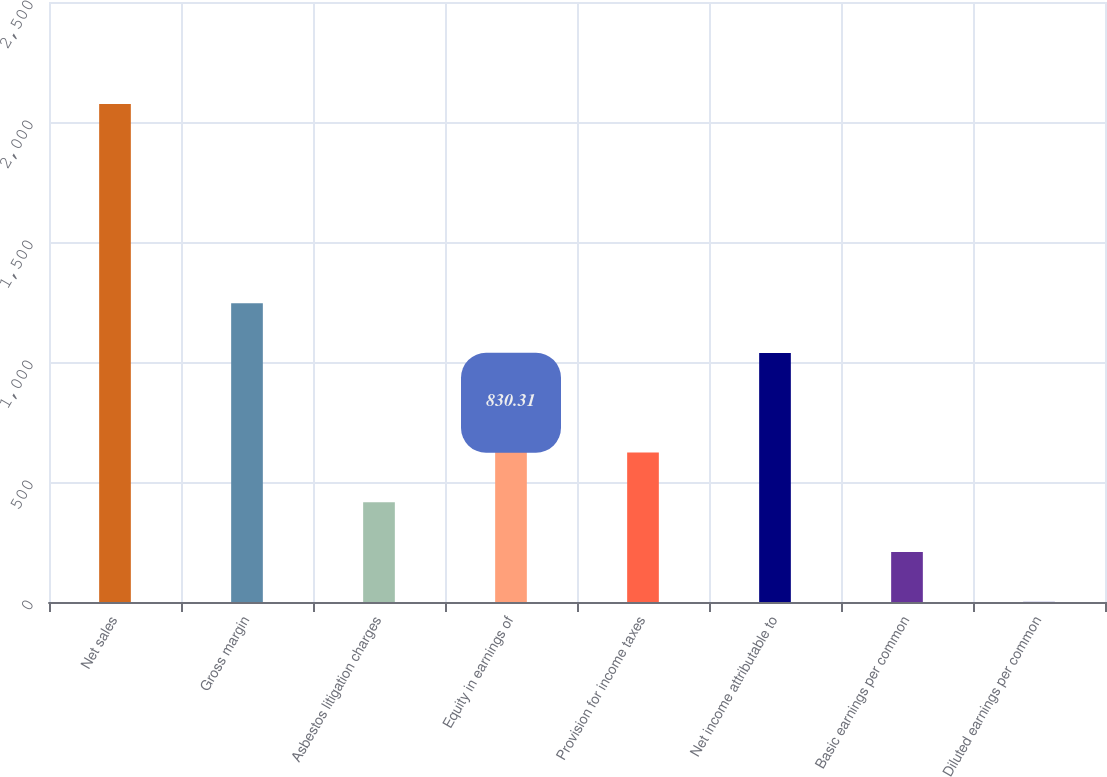Convert chart. <chart><loc_0><loc_0><loc_500><loc_500><bar_chart><fcel>Net sales<fcel>Gross margin<fcel>Asbestos litigation charges<fcel>Equity in earnings of<fcel>Provision for income taxes<fcel>Net income attributable to<fcel>Basic earnings per common<fcel>Diluted earnings per common<nl><fcel>2075<fcel>1245.21<fcel>415.41<fcel>830.31<fcel>622.86<fcel>1037.76<fcel>207.96<fcel>0.51<nl></chart> 